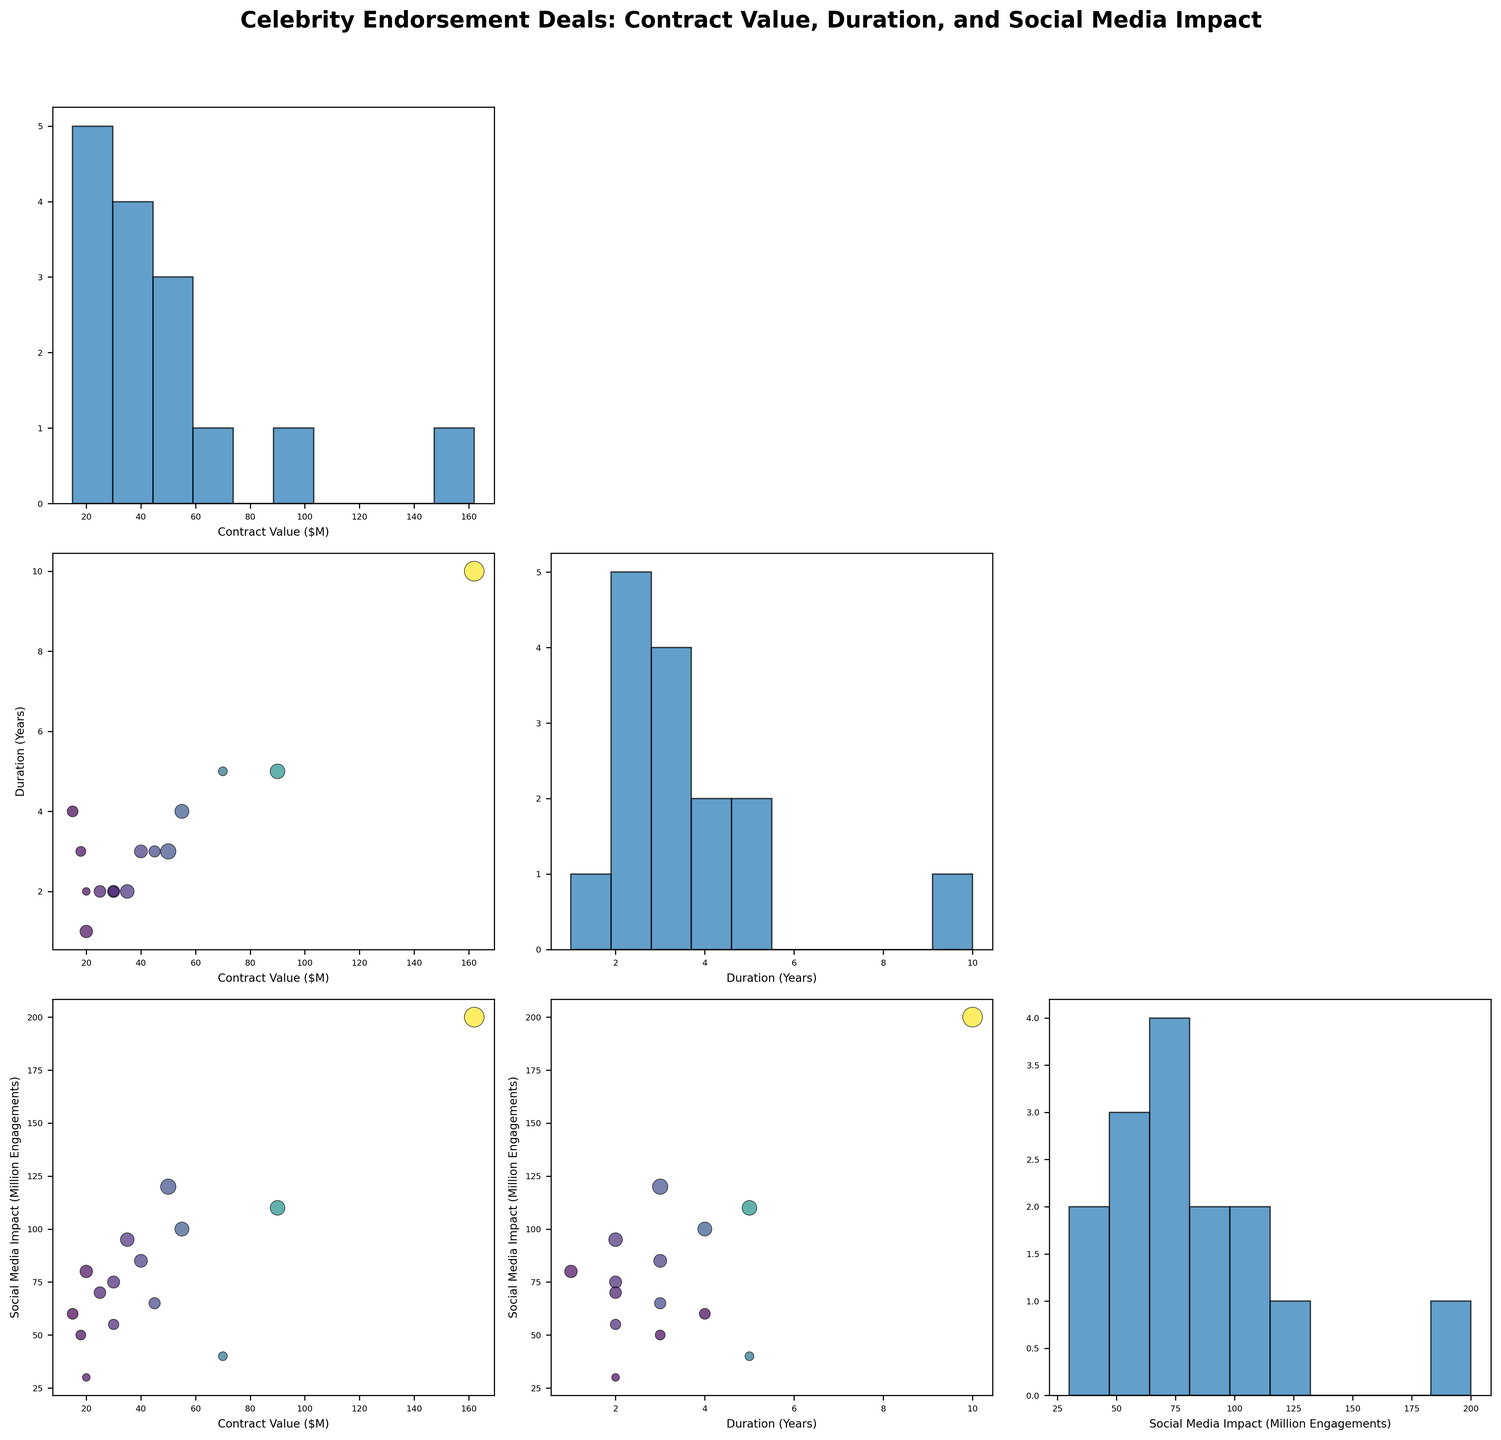What's the title of the scatterplot matrix? The title is located at the top center of the scatterplot matrix. The title summarizes the main focus of the figure. In this case, the title is "Celebrity Endorsement Deals: Contract Value, Duration, and Social Media Impact."
Answer: Celebrity Endorsement Deals: Contract Value, Duration, and Social Media Impact How many variables are plotted in the scatterplot matrix? The number of variables can be determined by counting the axes labels along each row and column or recognizing that the scatterplot matrix shows combinations of three variables: 'Contract Value ($M)', 'Duration (Years)', and 'Social Media Impact (Million Engagements).'
Answer: Three Which variables are plotted on the x- and y-axes of the scatterplot in the top right subplot? To determine the x- and y-axes, refer to the labels provided for each axis in the subplot matrix. The top right subplot (first row, third column) will have 'Social Media Impact (Million Engagements)' on the x-axis and 'Contract Value ($M)' on the y-axis.
Answer: Social Media Impact (Million Engagements) on x-axis; Contract Value ($M) on y-axis What is the approximate range of social media impact values for celebrity endorsement deals? Examine the x-axis range for the 'Social Media Impact (Million Engagements)' in scatterplots and histograms where it is the variable. The range appears to span from approximately 30 million to 200 million engagements.
Answer: 30 million to 200 million Which celebrity has the highest contract value, and what is that value? Look for the data point farthest to the right on the scatterplots involving the 'Contract Value ($M)' variable. Cristiano Ronaldo's data point, shown with high values across plots, corresponds to a contract value of $162 million.
Answer: Cristiano Ronaldo, $162 million Compare the duration of endorsement contracts between Beyoncé and LeBron James. Find the corresponding data points for both celebrities in plots involving 'Duration (Years).' Count the grid ticks to determine each value: Beyoncé's duration is 3 years, while LeBron James' is 5 years.
Answer: Beyoncé: 3 years, LeBron James: 5 years Which celebrity has the highest social media impact and what is their engagement value? Identify the data point farthest upward in the plots involving 'Social Media Impact (Million Engagements).' Cristiano Ronaldo's data point indicates the highest engagement value of around 200 million.
Answer: Cristiano Ronaldo, 200 million Is there a general trend or relationship visible between contract value and social media impact? Observe scatterplots where 'Contract Value ($M)' and 'Social Media Impact (Million Engagements)' are compared. Look for patterns or correlations such as upward or downward trends. A positive association is visible, indicating that higher contract values often correspond with higher social media impacts.
Answer: Positive relationship Which industry has the shortest average contract duration? Segment celebrities by industry and find their corresponding duration values from plots. Calculate average duration for each industry, noting that industries like 'Beauty' (Kylie Jenner, 1 year) have shorter durations compared to others.
Answer: Beauty What is the distribution of contract values among the celebrities? Locate the histogram for 'Contract Value ($M)' to understand its frequency distribution. The shape shows a wide range, with a notable concentration around lower to mid-range values (e.g., several points between 15-50 million dollars).
Answer: Wide range with concentrations between 15-50 million dollars 